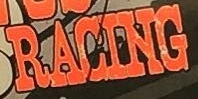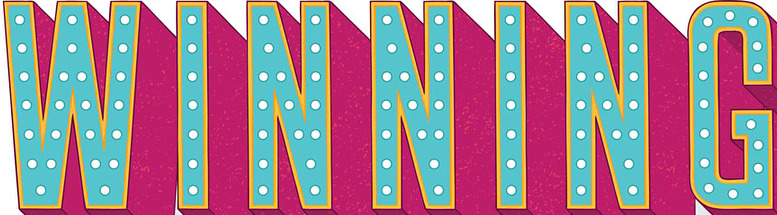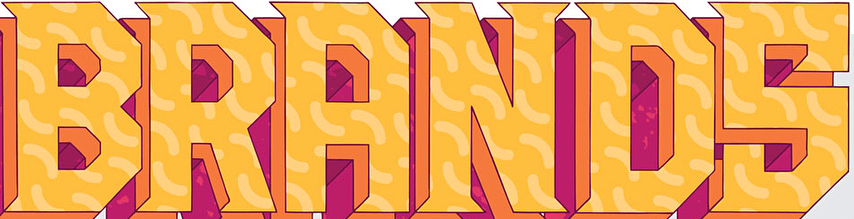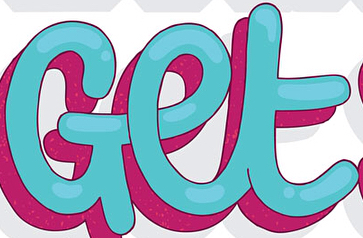Transcribe the words shown in these images in order, separated by a semicolon. RACING; WINNING; BRANDS; Get 